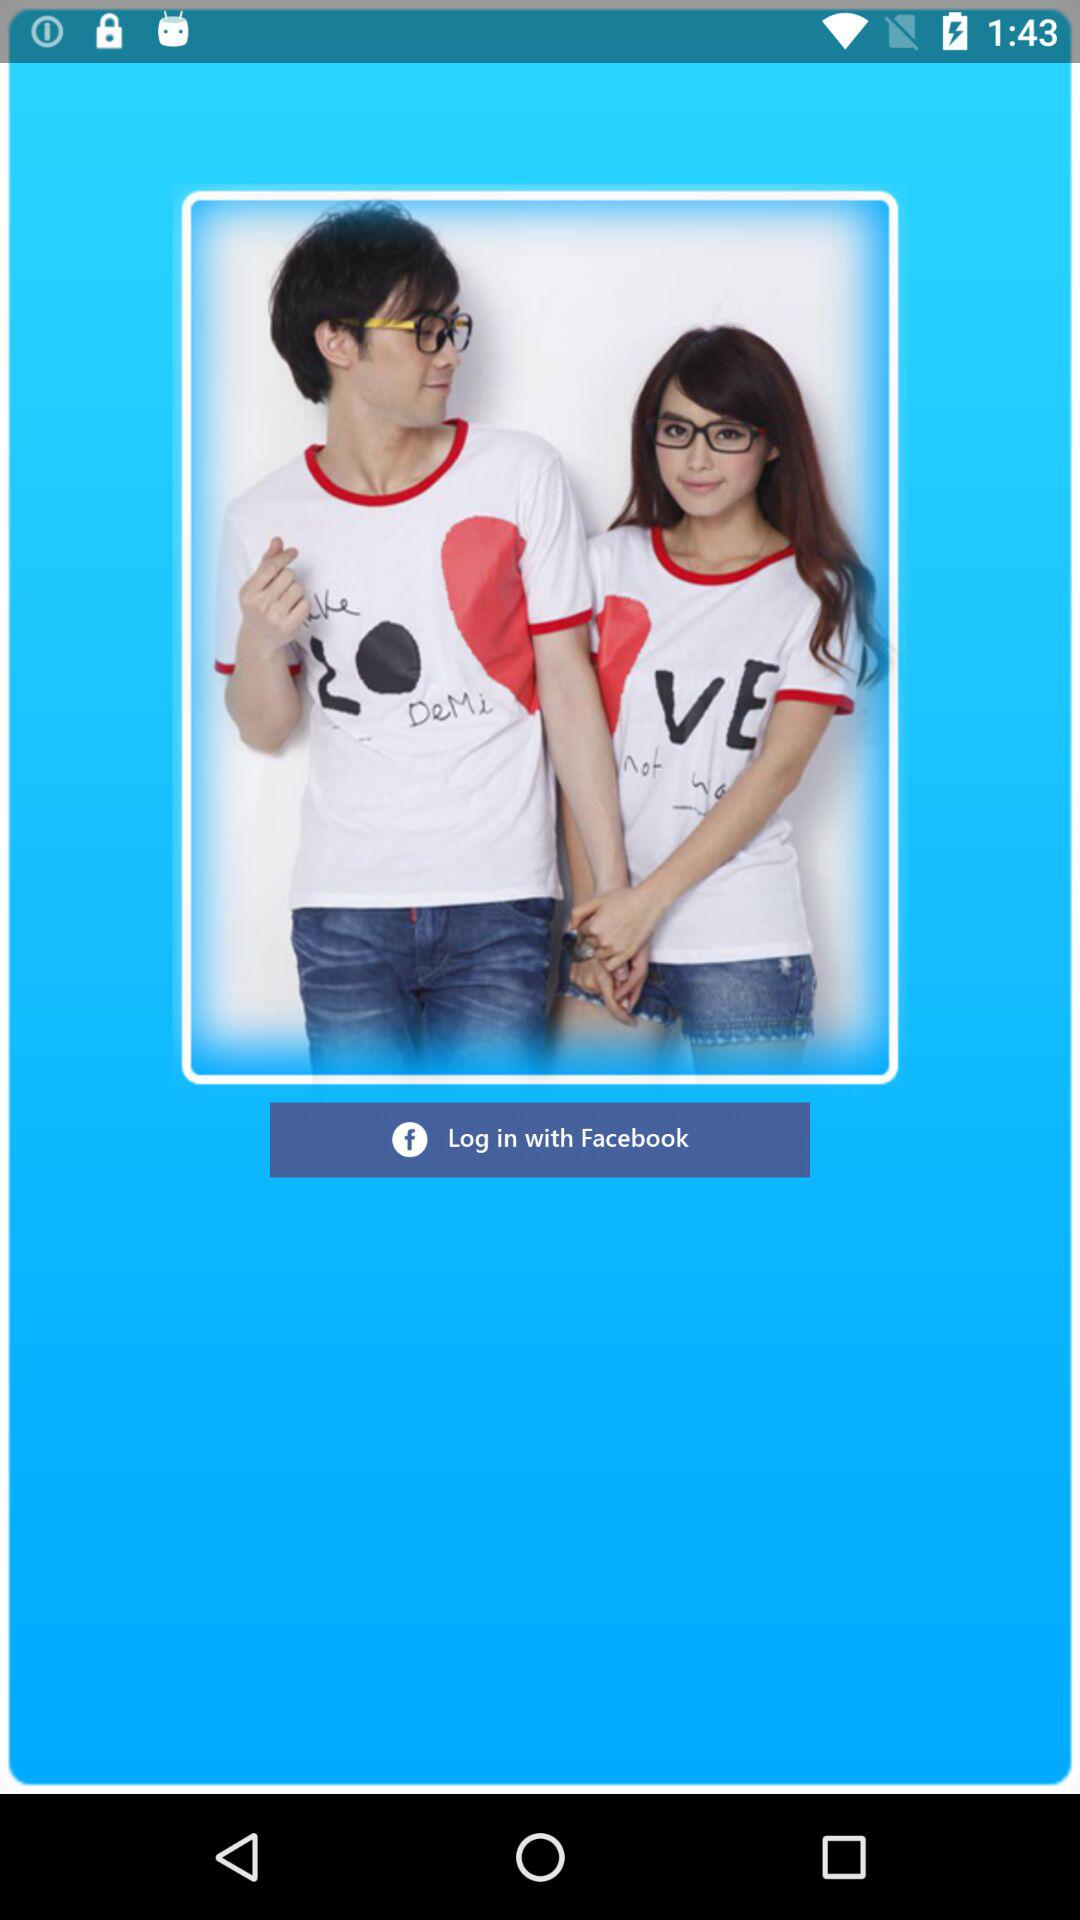Through what app can we log in? You can log in through "Facebook". 